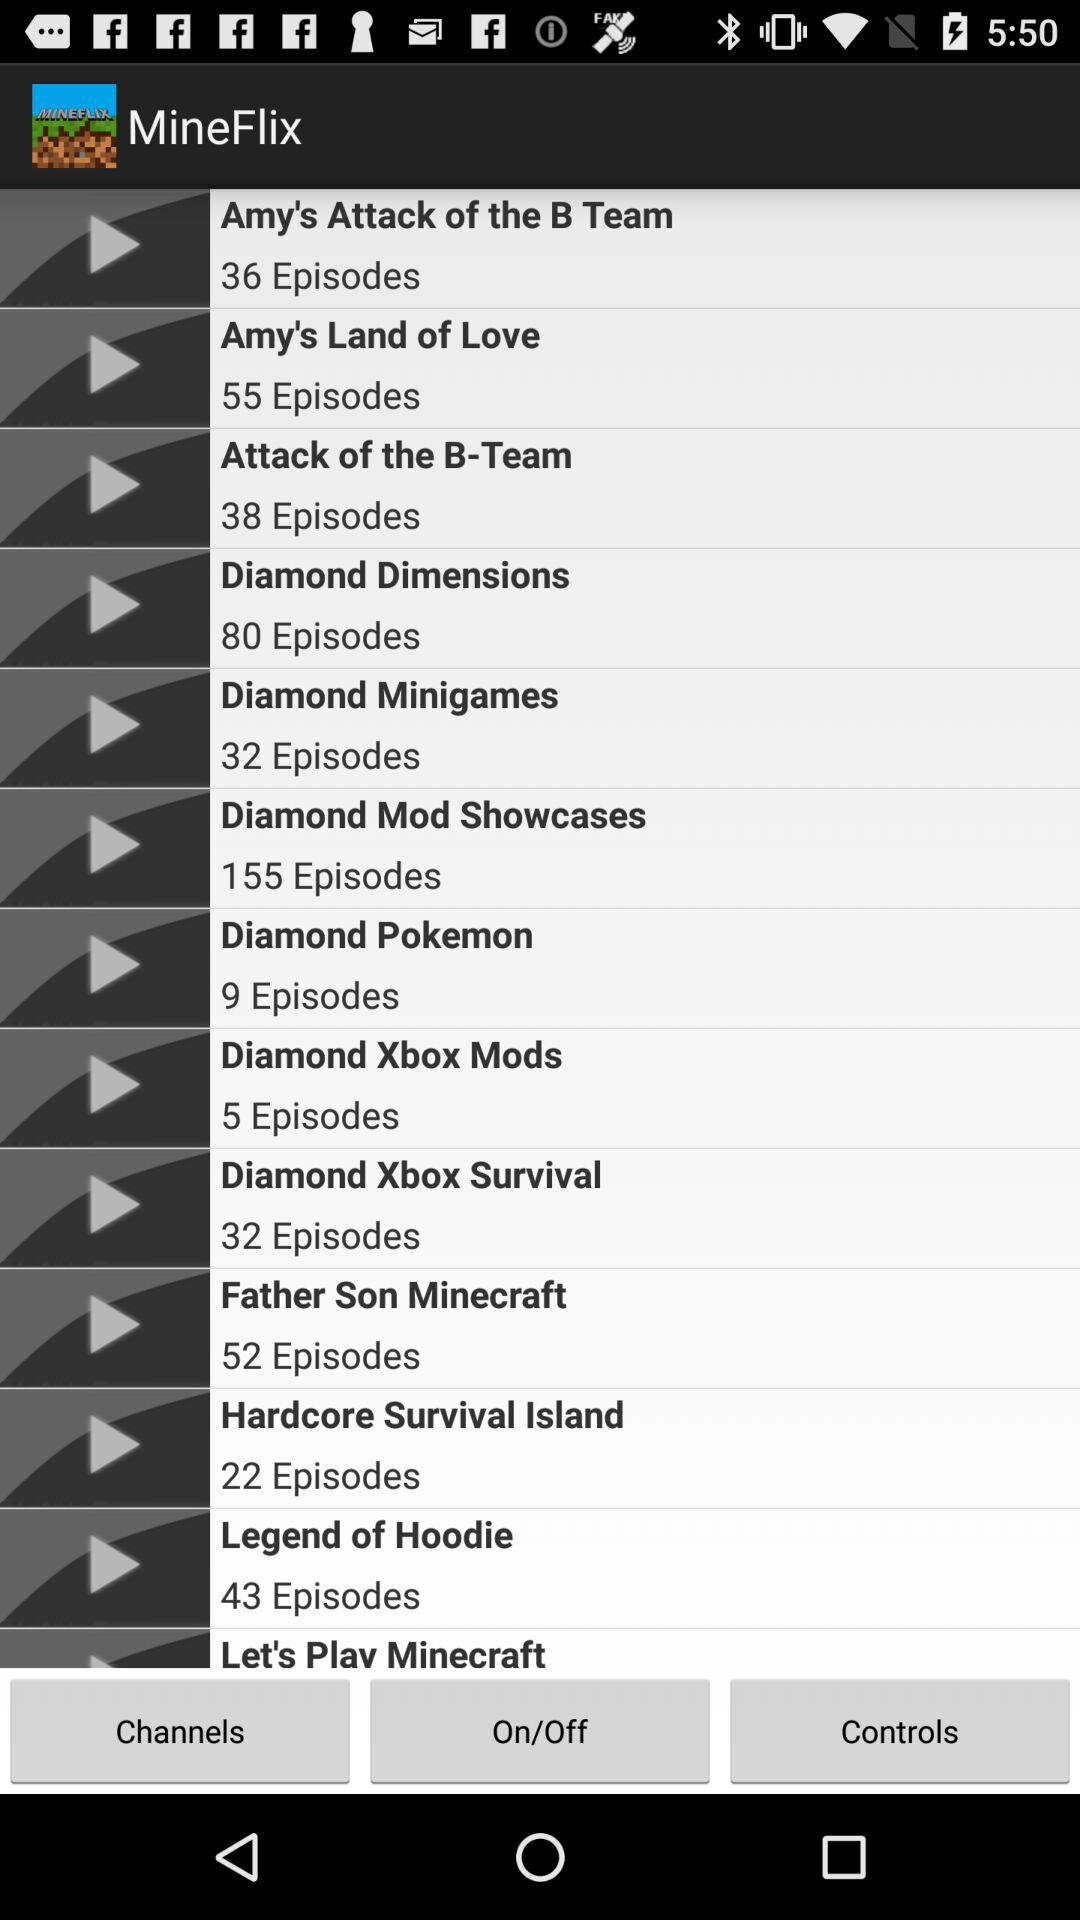How many episodes are there in the "Legend of Hoodie" series? There are 43 episodes in the "Legend of Hoodie" series. 